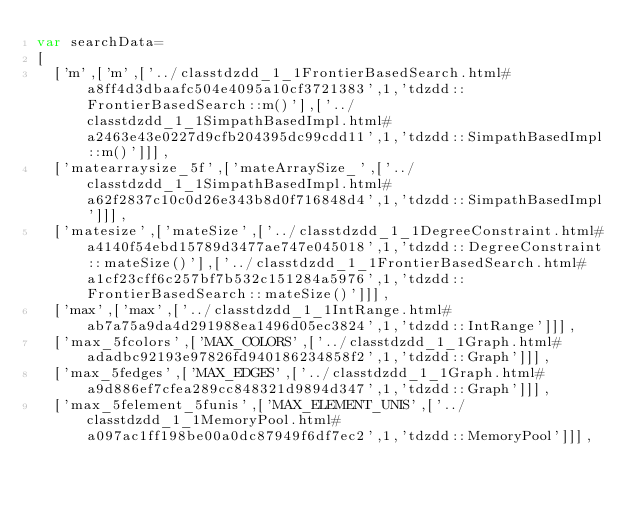<code> <loc_0><loc_0><loc_500><loc_500><_JavaScript_>var searchData=
[
  ['m',['m',['../classtdzdd_1_1FrontierBasedSearch.html#a8ff4d3dbaafc504e4095a10cf3721383',1,'tdzdd::FrontierBasedSearch::m()'],['../classtdzdd_1_1SimpathBasedImpl.html#a2463e43e0227d9cfb204395dc99cdd11',1,'tdzdd::SimpathBasedImpl::m()']]],
  ['matearraysize_5f',['mateArraySize_',['../classtdzdd_1_1SimpathBasedImpl.html#a62f2837c10c0d26e343b8d0f716848d4',1,'tdzdd::SimpathBasedImpl']]],
  ['matesize',['mateSize',['../classtdzdd_1_1DegreeConstraint.html#a4140f54ebd15789d3477ae747e045018',1,'tdzdd::DegreeConstraint::mateSize()'],['../classtdzdd_1_1FrontierBasedSearch.html#a1cf23cff6c257bf7b532c151284a5976',1,'tdzdd::FrontierBasedSearch::mateSize()']]],
  ['max',['max',['../classtdzdd_1_1IntRange.html#ab7a75a9da4d291988ea1496d05ec3824',1,'tdzdd::IntRange']]],
  ['max_5fcolors',['MAX_COLORS',['../classtdzdd_1_1Graph.html#adadbc92193e97826fd940186234858f2',1,'tdzdd::Graph']]],
  ['max_5fedges',['MAX_EDGES',['../classtdzdd_1_1Graph.html#a9d886ef7cfea289cc848321d9894d347',1,'tdzdd::Graph']]],
  ['max_5felement_5funis',['MAX_ELEMENT_UNIS',['../classtdzdd_1_1MemoryPool.html#a097ac1ff198be00a0dc87949f6df7ec2',1,'tdzdd::MemoryPool']]],</code> 